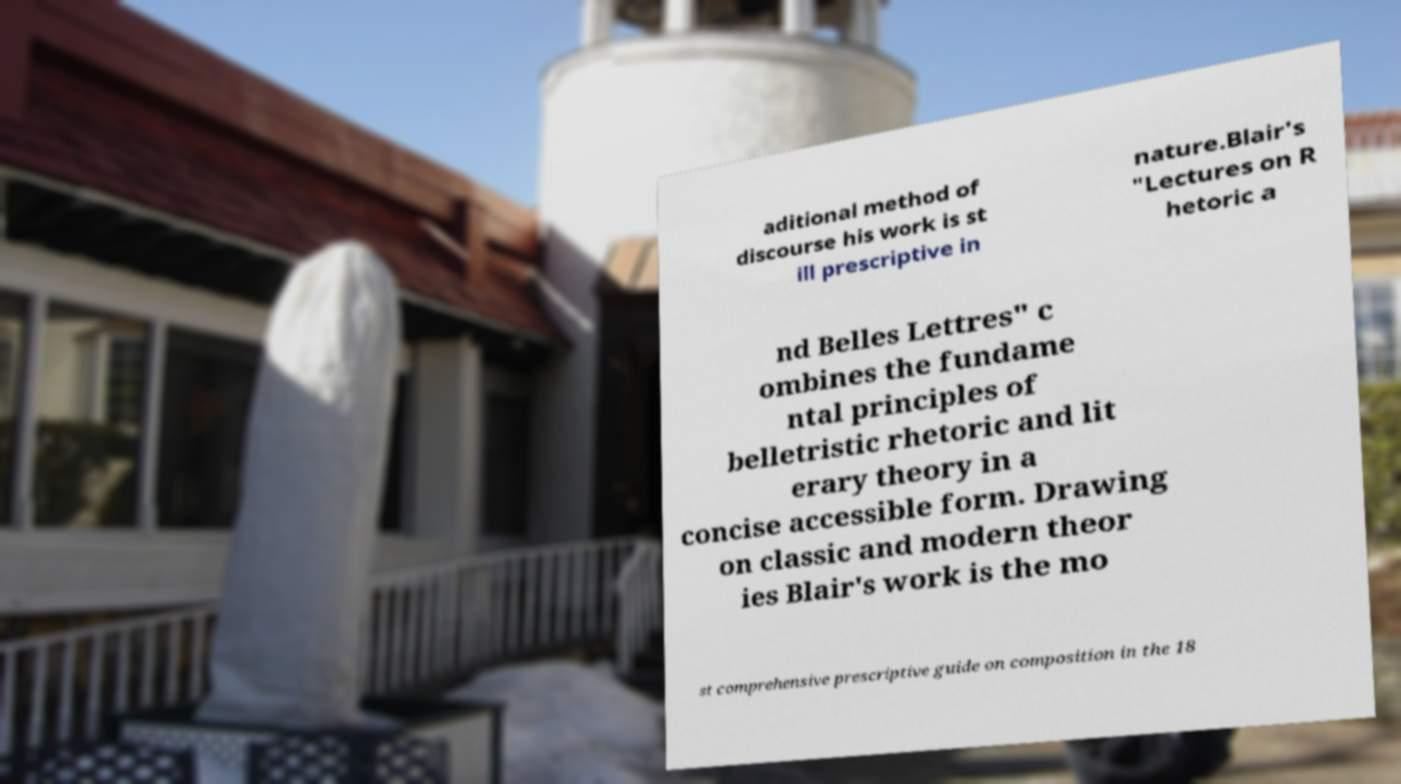I need the written content from this picture converted into text. Can you do that? aditional method of discourse his work is st ill prescriptive in nature.Blair's "Lectures on R hetoric a nd Belles Lettres" c ombines the fundame ntal principles of belletristic rhetoric and lit erary theory in a concise accessible form. Drawing on classic and modern theor ies Blair's work is the mo st comprehensive prescriptive guide on composition in the 18 